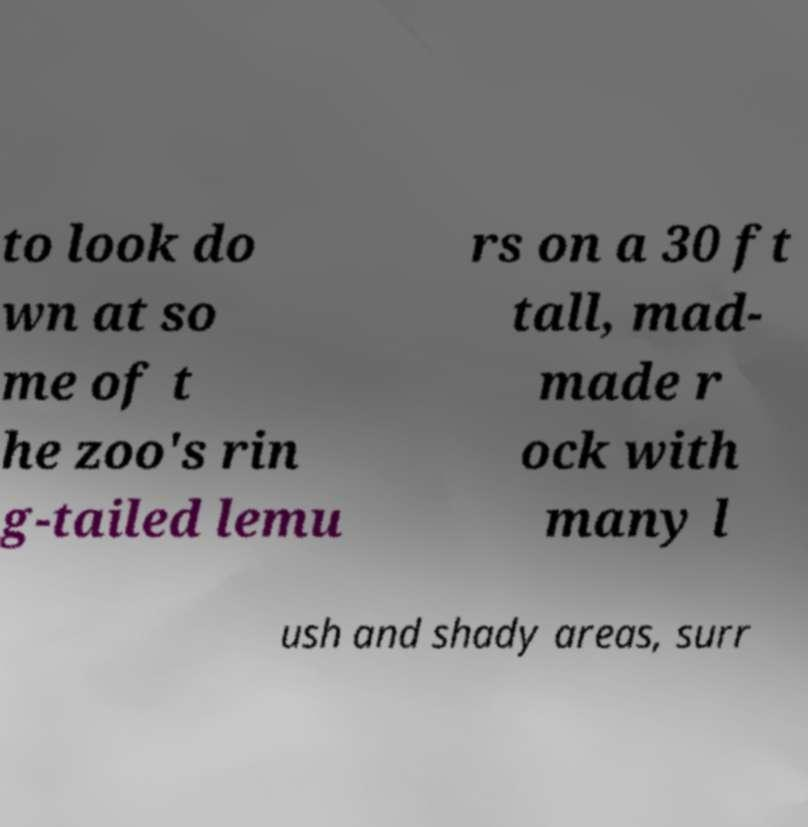Can you accurately transcribe the text from the provided image for me? to look do wn at so me of t he zoo's rin g-tailed lemu rs on a 30 ft tall, mad- made r ock with many l ush and shady areas, surr 